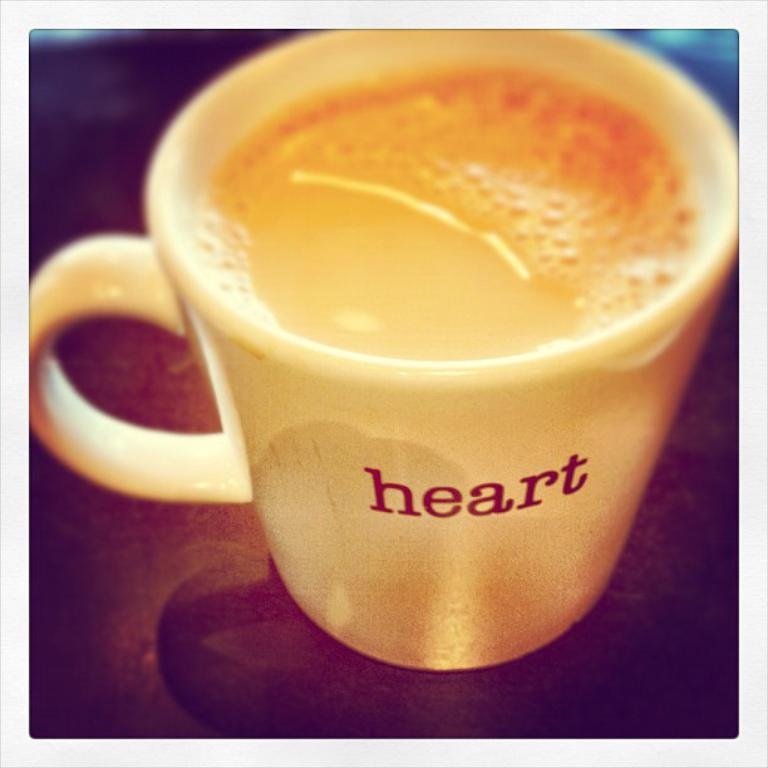What is present in the image that can hold a liquid? There is a cup in the image that can hold a liquid. What is the color or material of the surface the cup is on? The cup is on a brown surface. What is inside the cup? There is a drink in the cup. Is there any text or design on the cup? Yes, the word "heart" is written on the cup. What type of rod can be seen holding up the cup in the image? There is no rod present in the image; the cup is simply sitting on a brown surface. 